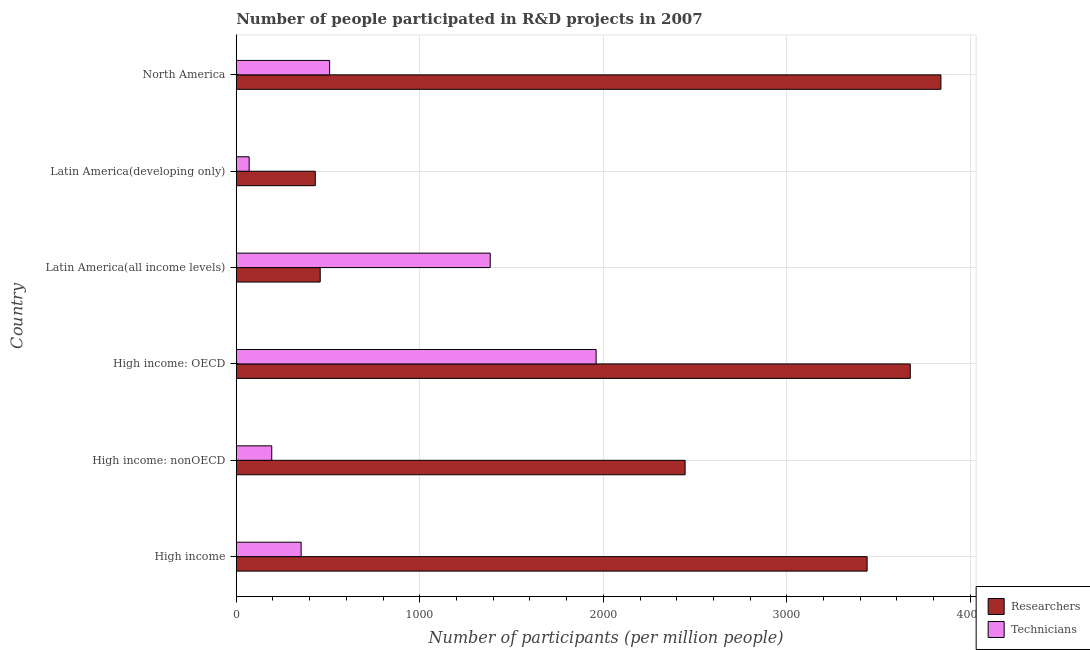How many different coloured bars are there?
Offer a very short reply. 2. Are the number of bars on each tick of the Y-axis equal?
Make the answer very short. Yes. How many bars are there on the 5th tick from the bottom?
Keep it short and to the point. 2. What is the label of the 4th group of bars from the top?
Ensure brevity in your answer.  High income: OECD. In how many cases, is the number of bars for a given country not equal to the number of legend labels?
Offer a terse response. 0. What is the number of technicians in High income: nonOECD?
Your answer should be compact. 193.45. Across all countries, what is the maximum number of technicians?
Your answer should be very brief. 1960.89. Across all countries, what is the minimum number of researchers?
Offer a very short reply. 430.59. In which country was the number of technicians maximum?
Give a very brief answer. High income: OECD. In which country was the number of researchers minimum?
Ensure brevity in your answer.  Latin America(developing only). What is the total number of technicians in the graph?
Offer a terse response. 4470.89. What is the difference between the number of technicians in High income: nonOECD and that in North America?
Ensure brevity in your answer.  -315.3. What is the difference between the number of researchers in High income and the number of technicians in Latin America(developing only)?
Give a very brief answer. 3367.19. What is the average number of researchers per country?
Provide a short and direct response. 2380.56. What is the difference between the number of technicians and number of researchers in North America?
Provide a succinct answer. -3330.78. In how many countries, is the number of technicians greater than 1800 ?
Provide a succinct answer. 1. What is the ratio of the number of researchers in High income: OECD to that in Latin America(developing only)?
Keep it short and to the point. 8.53. Is the number of technicians in High income: nonOECD less than that in North America?
Give a very brief answer. Yes. Is the difference between the number of technicians in High income and Latin America(all income levels) greater than the difference between the number of researchers in High income and Latin America(all income levels)?
Ensure brevity in your answer.  No. What is the difference between the highest and the second highest number of technicians?
Your response must be concise. 576.95. What is the difference between the highest and the lowest number of researchers?
Provide a succinct answer. 3408.94. What does the 1st bar from the top in High income: OECD represents?
Give a very brief answer. Technicians. What does the 2nd bar from the bottom in High income: nonOECD represents?
Offer a terse response. Technicians. Are all the bars in the graph horizontal?
Your answer should be compact. Yes. Does the graph contain any zero values?
Your answer should be very brief. No. What is the title of the graph?
Your answer should be compact. Number of people participated in R&D projects in 2007. What is the label or title of the X-axis?
Give a very brief answer. Number of participants (per million people). What is the Number of participants (per million people) in Researchers in High income?
Offer a very short reply. 3437.47. What is the Number of participants (per million people) in Technicians in High income?
Offer a very short reply. 353.59. What is the Number of participants (per million people) in Researchers in High income: nonOECD?
Offer a terse response. 2445.66. What is the Number of participants (per million people) of Technicians in High income: nonOECD?
Offer a terse response. 193.45. What is the Number of participants (per million people) of Researchers in High income: OECD?
Ensure brevity in your answer.  3672.63. What is the Number of participants (per million people) of Technicians in High income: OECD?
Offer a very short reply. 1960.89. What is the Number of participants (per million people) of Researchers in Latin America(all income levels)?
Your answer should be compact. 457.47. What is the Number of participants (per million people) of Technicians in Latin America(all income levels)?
Your response must be concise. 1383.94. What is the Number of participants (per million people) in Researchers in Latin America(developing only)?
Your answer should be very brief. 430.59. What is the Number of participants (per million people) in Technicians in Latin America(developing only)?
Your answer should be very brief. 70.28. What is the Number of participants (per million people) in Researchers in North America?
Ensure brevity in your answer.  3839.52. What is the Number of participants (per million people) in Technicians in North America?
Make the answer very short. 508.75. Across all countries, what is the maximum Number of participants (per million people) of Researchers?
Your answer should be very brief. 3839.52. Across all countries, what is the maximum Number of participants (per million people) in Technicians?
Ensure brevity in your answer.  1960.89. Across all countries, what is the minimum Number of participants (per million people) of Researchers?
Your answer should be very brief. 430.59. Across all countries, what is the minimum Number of participants (per million people) of Technicians?
Your answer should be compact. 70.28. What is the total Number of participants (per million people) in Researchers in the graph?
Your response must be concise. 1.43e+04. What is the total Number of participants (per million people) in Technicians in the graph?
Keep it short and to the point. 4470.89. What is the difference between the Number of participants (per million people) in Researchers in High income and that in High income: nonOECD?
Keep it short and to the point. 991.81. What is the difference between the Number of participants (per million people) of Technicians in High income and that in High income: nonOECD?
Offer a very short reply. 160.14. What is the difference between the Number of participants (per million people) in Researchers in High income and that in High income: OECD?
Offer a very short reply. -235.16. What is the difference between the Number of participants (per million people) of Technicians in High income and that in High income: OECD?
Ensure brevity in your answer.  -1607.3. What is the difference between the Number of participants (per million people) of Researchers in High income and that in Latin America(all income levels)?
Give a very brief answer. 2980.01. What is the difference between the Number of participants (per million people) of Technicians in High income and that in Latin America(all income levels)?
Provide a succinct answer. -1030.35. What is the difference between the Number of participants (per million people) in Researchers in High income and that in Latin America(developing only)?
Provide a succinct answer. 3006.88. What is the difference between the Number of participants (per million people) in Technicians in High income and that in Latin America(developing only)?
Provide a short and direct response. 283.3. What is the difference between the Number of participants (per million people) of Researchers in High income and that in North America?
Your response must be concise. -402.05. What is the difference between the Number of participants (per million people) of Technicians in High income and that in North America?
Offer a very short reply. -155.16. What is the difference between the Number of participants (per million people) in Researchers in High income: nonOECD and that in High income: OECD?
Provide a succinct answer. -1226.97. What is the difference between the Number of participants (per million people) of Technicians in High income: nonOECD and that in High income: OECD?
Ensure brevity in your answer.  -1767.44. What is the difference between the Number of participants (per million people) in Researchers in High income: nonOECD and that in Latin America(all income levels)?
Your answer should be compact. 1988.2. What is the difference between the Number of participants (per million people) of Technicians in High income: nonOECD and that in Latin America(all income levels)?
Make the answer very short. -1190.49. What is the difference between the Number of participants (per million people) of Researchers in High income: nonOECD and that in Latin America(developing only)?
Offer a terse response. 2015.08. What is the difference between the Number of participants (per million people) in Technicians in High income: nonOECD and that in Latin America(developing only)?
Make the answer very short. 123.16. What is the difference between the Number of participants (per million people) of Researchers in High income: nonOECD and that in North America?
Your answer should be compact. -1393.86. What is the difference between the Number of participants (per million people) of Technicians in High income: nonOECD and that in North America?
Offer a terse response. -315.3. What is the difference between the Number of participants (per million people) in Researchers in High income: OECD and that in Latin America(all income levels)?
Offer a terse response. 3215.17. What is the difference between the Number of participants (per million people) of Technicians in High income: OECD and that in Latin America(all income levels)?
Make the answer very short. 576.95. What is the difference between the Number of participants (per million people) in Researchers in High income: OECD and that in Latin America(developing only)?
Provide a short and direct response. 3242.05. What is the difference between the Number of participants (per million people) of Technicians in High income: OECD and that in Latin America(developing only)?
Your answer should be compact. 1890.6. What is the difference between the Number of participants (per million people) of Researchers in High income: OECD and that in North America?
Offer a very short reply. -166.89. What is the difference between the Number of participants (per million people) of Technicians in High income: OECD and that in North America?
Make the answer very short. 1452.14. What is the difference between the Number of participants (per million people) of Researchers in Latin America(all income levels) and that in Latin America(developing only)?
Your answer should be very brief. 26.88. What is the difference between the Number of participants (per million people) in Technicians in Latin America(all income levels) and that in Latin America(developing only)?
Provide a short and direct response. 1313.65. What is the difference between the Number of participants (per million people) in Researchers in Latin America(all income levels) and that in North America?
Offer a very short reply. -3382.06. What is the difference between the Number of participants (per million people) in Technicians in Latin America(all income levels) and that in North America?
Provide a short and direct response. 875.19. What is the difference between the Number of participants (per million people) of Researchers in Latin America(developing only) and that in North America?
Your answer should be very brief. -3408.94. What is the difference between the Number of participants (per million people) of Technicians in Latin America(developing only) and that in North America?
Your response must be concise. -438.47. What is the difference between the Number of participants (per million people) in Researchers in High income and the Number of participants (per million people) in Technicians in High income: nonOECD?
Make the answer very short. 3244.03. What is the difference between the Number of participants (per million people) of Researchers in High income and the Number of participants (per million people) of Technicians in High income: OECD?
Provide a short and direct response. 1476.58. What is the difference between the Number of participants (per million people) in Researchers in High income and the Number of participants (per million people) in Technicians in Latin America(all income levels)?
Provide a short and direct response. 2053.53. What is the difference between the Number of participants (per million people) of Researchers in High income and the Number of participants (per million people) of Technicians in Latin America(developing only)?
Give a very brief answer. 3367.19. What is the difference between the Number of participants (per million people) of Researchers in High income and the Number of participants (per million people) of Technicians in North America?
Offer a very short reply. 2928.72. What is the difference between the Number of participants (per million people) of Researchers in High income: nonOECD and the Number of participants (per million people) of Technicians in High income: OECD?
Your answer should be very brief. 484.77. What is the difference between the Number of participants (per million people) of Researchers in High income: nonOECD and the Number of participants (per million people) of Technicians in Latin America(all income levels)?
Make the answer very short. 1061.73. What is the difference between the Number of participants (per million people) in Researchers in High income: nonOECD and the Number of participants (per million people) in Technicians in Latin America(developing only)?
Give a very brief answer. 2375.38. What is the difference between the Number of participants (per million people) in Researchers in High income: nonOECD and the Number of participants (per million people) in Technicians in North America?
Your answer should be very brief. 1936.91. What is the difference between the Number of participants (per million people) of Researchers in High income: OECD and the Number of participants (per million people) of Technicians in Latin America(all income levels)?
Offer a very short reply. 2288.7. What is the difference between the Number of participants (per million people) in Researchers in High income: OECD and the Number of participants (per million people) in Technicians in Latin America(developing only)?
Your answer should be compact. 3602.35. What is the difference between the Number of participants (per million people) in Researchers in High income: OECD and the Number of participants (per million people) in Technicians in North America?
Offer a terse response. 3163.88. What is the difference between the Number of participants (per million people) of Researchers in Latin America(all income levels) and the Number of participants (per million people) of Technicians in Latin America(developing only)?
Ensure brevity in your answer.  387.18. What is the difference between the Number of participants (per million people) in Researchers in Latin America(all income levels) and the Number of participants (per million people) in Technicians in North America?
Ensure brevity in your answer.  -51.28. What is the difference between the Number of participants (per million people) of Researchers in Latin America(developing only) and the Number of participants (per million people) of Technicians in North America?
Offer a very short reply. -78.16. What is the average Number of participants (per million people) of Researchers per country?
Provide a succinct answer. 2380.56. What is the average Number of participants (per million people) in Technicians per country?
Your answer should be compact. 745.15. What is the difference between the Number of participants (per million people) of Researchers and Number of participants (per million people) of Technicians in High income?
Provide a succinct answer. 3083.88. What is the difference between the Number of participants (per million people) in Researchers and Number of participants (per million people) in Technicians in High income: nonOECD?
Keep it short and to the point. 2252.22. What is the difference between the Number of participants (per million people) in Researchers and Number of participants (per million people) in Technicians in High income: OECD?
Provide a short and direct response. 1711.74. What is the difference between the Number of participants (per million people) in Researchers and Number of participants (per million people) in Technicians in Latin America(all income levels)?
Ensure brevity in your answer.  -926.47. What is the difference between the Number of participants (per million people) of Researchers and Number of participants (per million people) of Technicians in Latin America(developing only)?
Your answer should be very brief. 360.3. What is the difference between the Number of participants (per million people) in Researchers and Number of participants (per million people) in Technicians in North America?
Ensure brevity in your answer.  3330.77. What is the ratio of the Number of participants (per million people) in Researchers in High income to that in High income: nonOECD?
Your response must be concise. 1.41. What is the ratio of the Number of participants (per million people) of Technicians in High income to that in High income: nonOECD?
Keep it short and to the point. 1.83. What is the ratio of the Number of participants (per million people) of Researchers in High income to that in High income: OECD?
Offer a terse response. 0.94. What is the ratio of the Number of participants (per million people) in Technicians in High income to that in High income: OECD?
Your response must be concise. 0.18. What is the ratio of the Number of participants (per million people) in Researchers in High income to that in Latin America(all income levels)?
Your answer should be very brief. 7.51. What is the ratio of the Number of participants (per million people) in Technicians in High income to that in Latin America(all income levels)?
Offer a very short reply. 0.26. What is the ratio of the Number of participants (per million people) in Researchers in High income to that in Latin America(developing only)?
Keep it short and to the point. 7.98. What is the ratio of the Number of participants (per million people) in Technicians in High income to that in Latin America(developing only)?
Offer a very short reply. 5.03. What is the ratio of the Number of participants (per million people) of Researchers in High income to that in North America?
Your answer should be compact. 0.9. What is the ratio of the Number of participants (per million people) of Technicians in High income to that in North America?
Ensure brevity in your answer.  0.69. What is the ratio of the Number of participants (per million people) of Researchers in High income: nonOECD to that in High income: OECD?
Your answer should be very brief. 0.67. What is the ratio of the Number of participants (per million people) in Technicians in High income: nonOECD to that in High income: OECD?
Keep it short and to the point. 0.1. What is the ratio of the Number of participants (per million people) in Researchers in High income: nonOECD to that in Latin America(all income levels)?
Offer a very short reply. 5.35. What is the ratio of the Number of participants (per million people) in Technicians in High income: nonOECD to that in Latin America(all income levels)?
Your response must be concise. 0.14. What is the ratio of the Number of participants (per million people) of Researchers in High income: nonOECD to that in Latin America(developing only)?
Your response must be concise. 5.68. What is the ratio of the Number of participants (per million people) in Technicians in High income: nonOECD to that in Latin America(developing only)?
Offer a very short reply. 2.75. What is the ratio of the Number of participants (per million people) of Researchers in High income: nonOECD to that in North America?
Provide a short and direct response. 0.64. What is the ratio of the Number of participants (per million people) in Technicians in High income: nonOECD to that in North America?
Keep it short and to the point. 0.38. What is the ratio of the Number of participants (per million people) of Researchers in High income: OECD to that in Latin America(all income levels)?
Give a very brief answer. 8.03. What is the ratio of the Number of participants (per million people) in Technicians in High income: OECD to that in Latin America(all income levels)?
Offer a very short reply. 1.42. What is the ratio of the Number of participants (per million people) of Researchers in High income: OECD to that in Latin America(developing only)?
Your answer should be very brief. 8.53. What is the ratio of the Number of participants (per million people) in Technicians in High income: OECD to that in Latin America(developing only)?
Give a very brief answer. 27.9. What is the ratio of the Number of participants (per million people) in Researchers in High income: OECD to that in North America?
Offer a terse response. 0.96. What is the ratio of the Number of participants (per million people) of Technicians in High income: OECD to that in North America?
Provide a short and direct response. 3.85. What is the ratio of the Number of participants (per million people) of Researchers in Latin America(all income levels) to that in Latin America(developing only)?
Ensure brevity in your answer.  1.06. What is the ratio of the Number of participants (per million people) in Technicians in Latin America(all income levels) to that in Latin America(developing only)?
Offer a terse response. 19.69. What is the ratio of the Number of participants (per million people) in Researchers in Latin America(all income levels) to that in North America?
Provide a succinct answer. 0.12. What is the ratio of the Number of participants (per million people) of Technicians in Latin America(all income levels) to that in North America?
Offer a very short reply. 2.72. What is the ratio of the Number of participants (per million people) in Researchers in Latin America(developing only) to that in North America?
Provide a succinct answer. 0.11. What is the ratio of the Number of participants (per million people) of Technicians in Latin America(developing only) to that in North America?
Offer a very short reply. 0.14. What is the difference between the highest and the second highest Number of participants (per million people) in Researchers?
Keep it short and to the point. 166.89. What is the difference between the highest and the second highest Number of participants (per million people) of Technicians?
Make the answer very short. 576.95. What is the difference between the highest and the lowest Number of participants (per million people) of Researchers?
Offer a terse response. 3408.94. What is the difference between the highest and the lowest Number of participants (per million people) of Technicians?
Give a very brief answer. 1890.6. 